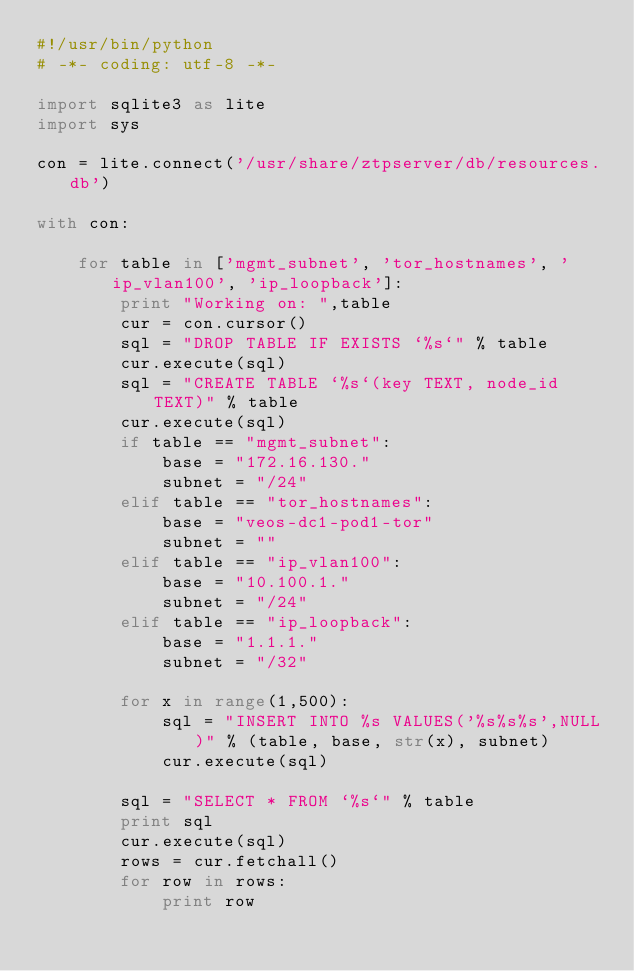Convert code to text. <code><loc_0><loc_0><loc_500><loc_500><_Python_>#!/usr/bin/python
# -*- coding: utf-8 -*-

import sqlite3 as lite
import sys

con = lite.connect('/usr/share/ztpserver/db/resources.db')

with con:

    for table in ['mgmt_subnet', 'tor_hostnames', 'ip_vlan100', 'ip_loopback']:
        print "Working on: ",table
        cur = con.cursor()
        sql = "DROP TABLE IF EXISTS `%s`" % table
        cur.execute(sql)
        sql = "CREATE TABLE `%s`(key TEXT, node_id TEXT)" % table
        cur.execute(sql)
        if table == "mgmt_subnet":
            base = "172.16.130."
            subnet = "/24"
        elif table == "tor_hostnames":
            base = "veos-dc1-pod1-tor"
            subnet = ""
        elif table == "ip_vlan100":
            base = "10.100.1."
            subnet = "/24"
        elif table == "ip_loopback":
            base = "1.1.1."
            subnet = "/32"

        for x in range(1,500):
            sql = "INSERT INTO %s VALUES('%s%s%s',NULL)" % (table, base, str(x), subnet)
            cur.execute(sql)

        sql = "SELECT * FROM `%s`" % table
        print sql
        cur.execute(sql)
        rows = cur.fetchall()
        for row in rows:
            print row
</code> 